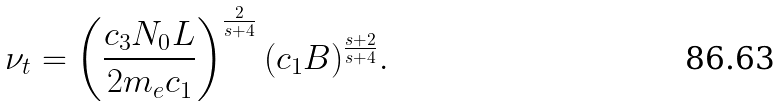Convert formula to latex. <formula><loc_0><loc_0><loc_500><loc_500>\nu _ { t } = \left ( \frac { c _ { 3 } N _ { 0 } L } { 2 m _ { e } c _ { 1 } } \right ) ^ { \frac { 2 } { s + 4 } } ( c _ { 1 } B ) ^ { \frac { s + 2 } { s + 4 } } .</formula> 